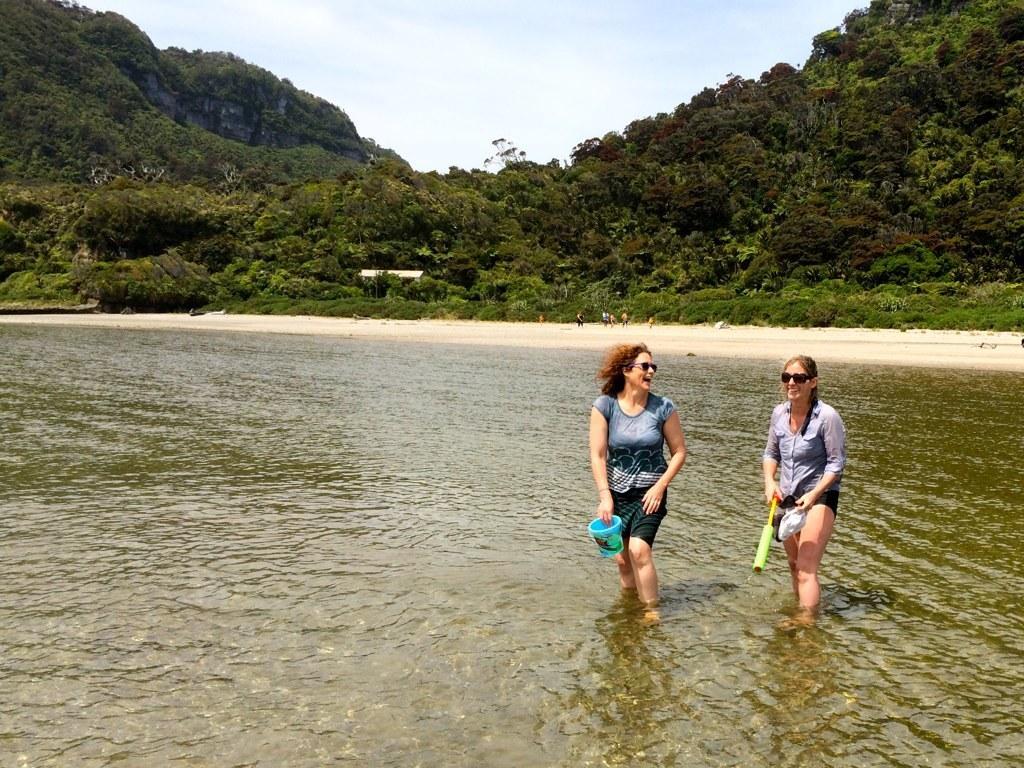Can you describe this image briefly? There are two women smiling and wore goggles and holding objects and we can see water. In the background of the image we can see trees, people and sky. 